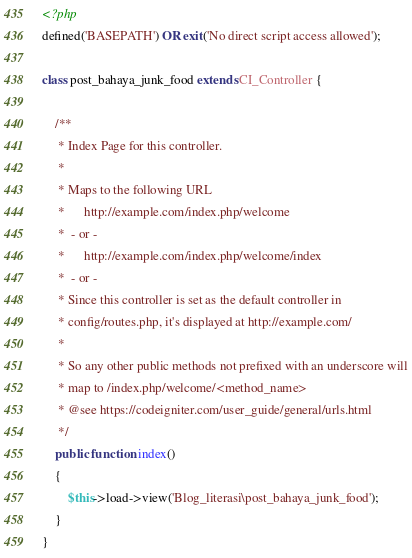<code> <loc_0><loc_0><loc_500><loc_500><_PHP_><?php
defined('BASEPATH') OR exit('No direct script access allowed');

class post_bahaya_junk_food extends CI_Controller {

	/**
	 * Index Page for this controller.
	 *
	 * Maps to the following URL
	 * 		http://example.com/index.php/welcome
	 *	- or -
	 * 		http://example.com/index.php/welcome/index
	 *	- or -
	 * Since this controller is set as the default controller in
	 * config/routes.php, it's displayed at http://example.com/
	 *
	 * So any other public methods not prefixed with an underscore will
	 * map to /index.php/welcome/<method_name>
	 * @see https://codeigniter.com/user_guide/general/urls.html
	 */
	public function index()
	{
		$this->load->view('Blog_literasi\post_bahaya_junk_food');
	}
}
</code> 